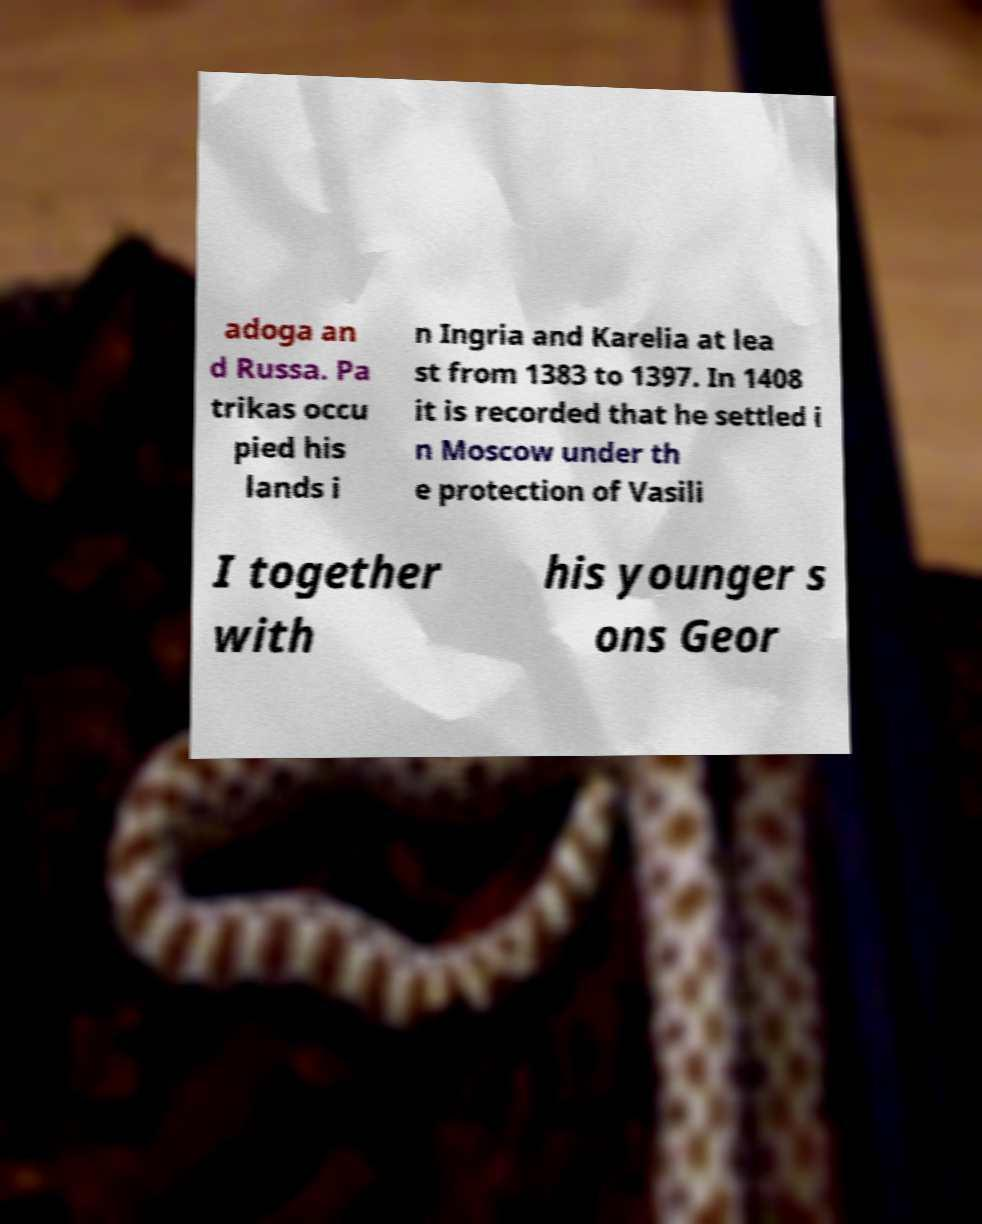Please read and relay the text visible in this image. What does it say? adoga an d Russa. Pa trikas occu pied his lands i n Ingria and Karelia at lea st from 1383 to 1397. In 1408 it is recorded that he settled i n Moscow under th e protection of Vasili I together with his younger s ons Geor 